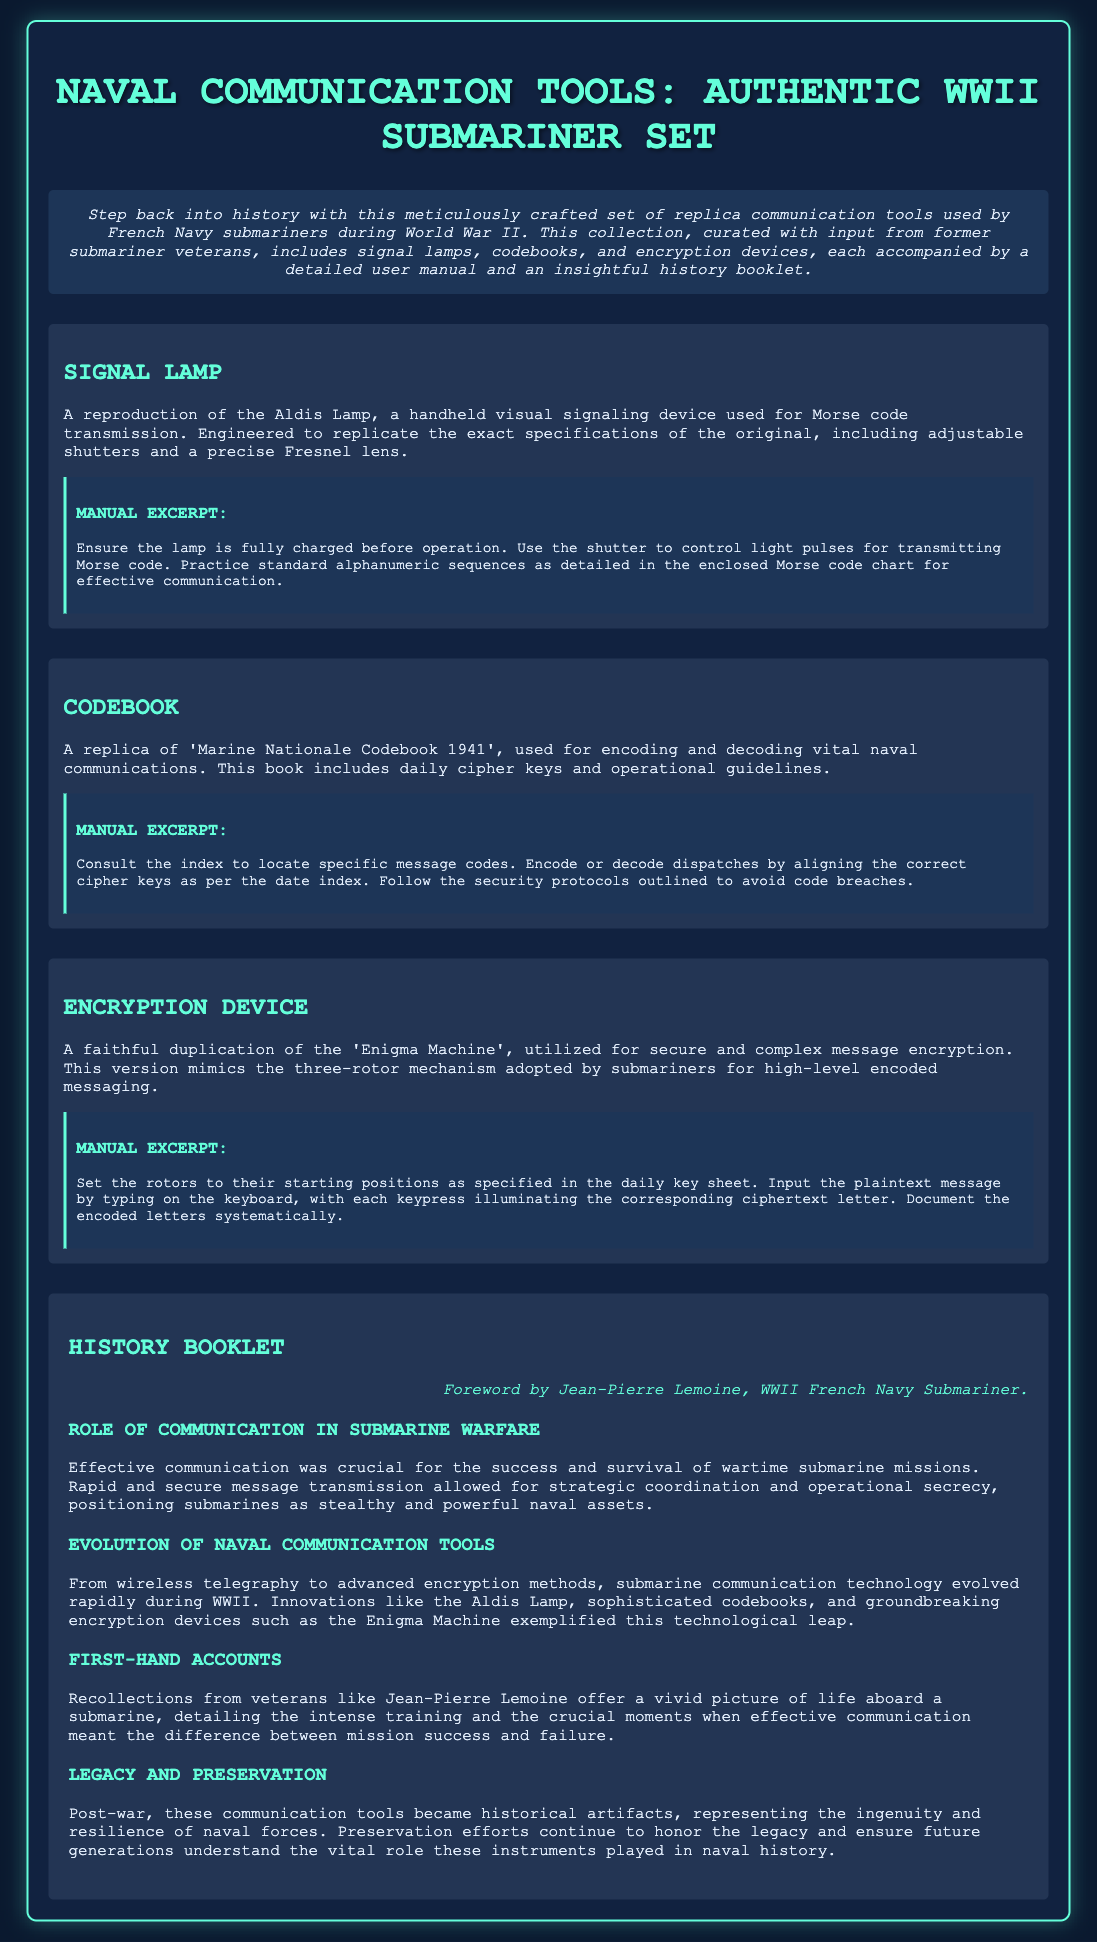what is the title of the product? The title of the product is mentioned at the top of the document.
Answer: Naval Communication Tools: Authentic WWII Submariner Set who authored the foreword? The foreword in the history booklet is attributed to a specific person.
Answer: Jean-Pierre Lemoine what device is a reproduction of the Aldis Lamp used for? The text describes the function of the Aldis Lamp in the context of communication tools.
Answer: Morse code transmission what year is the 'Marine Nationale Codebook' replica based on? The document specifies the year associated with the codebook replica.
Answer: 1941 how many rotors does the replica of the Enigma Machine have? The description of the Enigma Machine provides information on its components.
Answer: Three what is the historical significance of communication tools according to the booklet? The text outlines the importance of communication in submarine operations during the war.
Answer: Success and survival what kind of lighting does the signal lamp use? The specifications of the signal lamp highlight its functionality related to light.
Answer: Visual signaling how are dispatches encoded or decoded using the codebook? The manual excerpt describes the process for using the codebook effectively.
Answer: Aligning the correct cipher keys what is one key aspect of preserving naval communication tools mentioned in the document? The history section discusses efforts to maintain and honor these tools' legacy.
Answer: Preservation efforts continue 